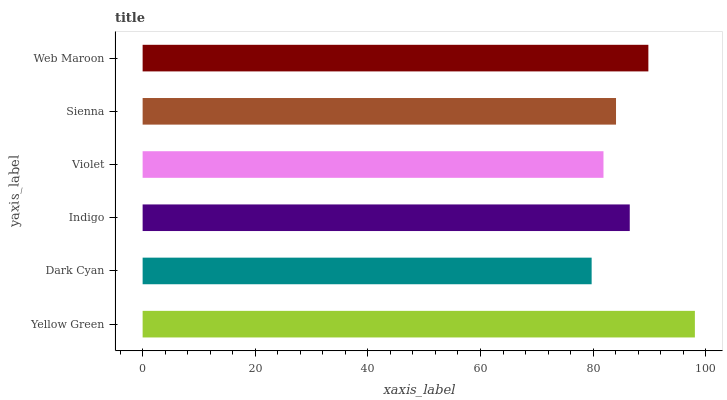Is Dark Cyan the minimum?
Answer yes or no. Yes. Is Yellow Green the maximum?
Answer yes or no. Yes. Is Indigo the minimum?
Answer yes or no. No. Is Indigo the maximum?
Answer yes or no. No. Is Indigo greater than Dark Cyan?
Answer yes or no. Yes. Is Dark Cyan less than Indigo?
Answer yes or no. Yes. Is Dark Cyan greater than Indigo?
Answer yes or no. No. Is Indigo less than Dark Cyan?
Answer yes or no. No. Is Indigo the high median?
Answer yes or no. Yes. Is Sienna the low median?
Answer yes or no. Yes. Is Dark Cyan the high median?
Answer yes or no. No. Is Dark Cyan the low median?
Answer yes or no. No. 